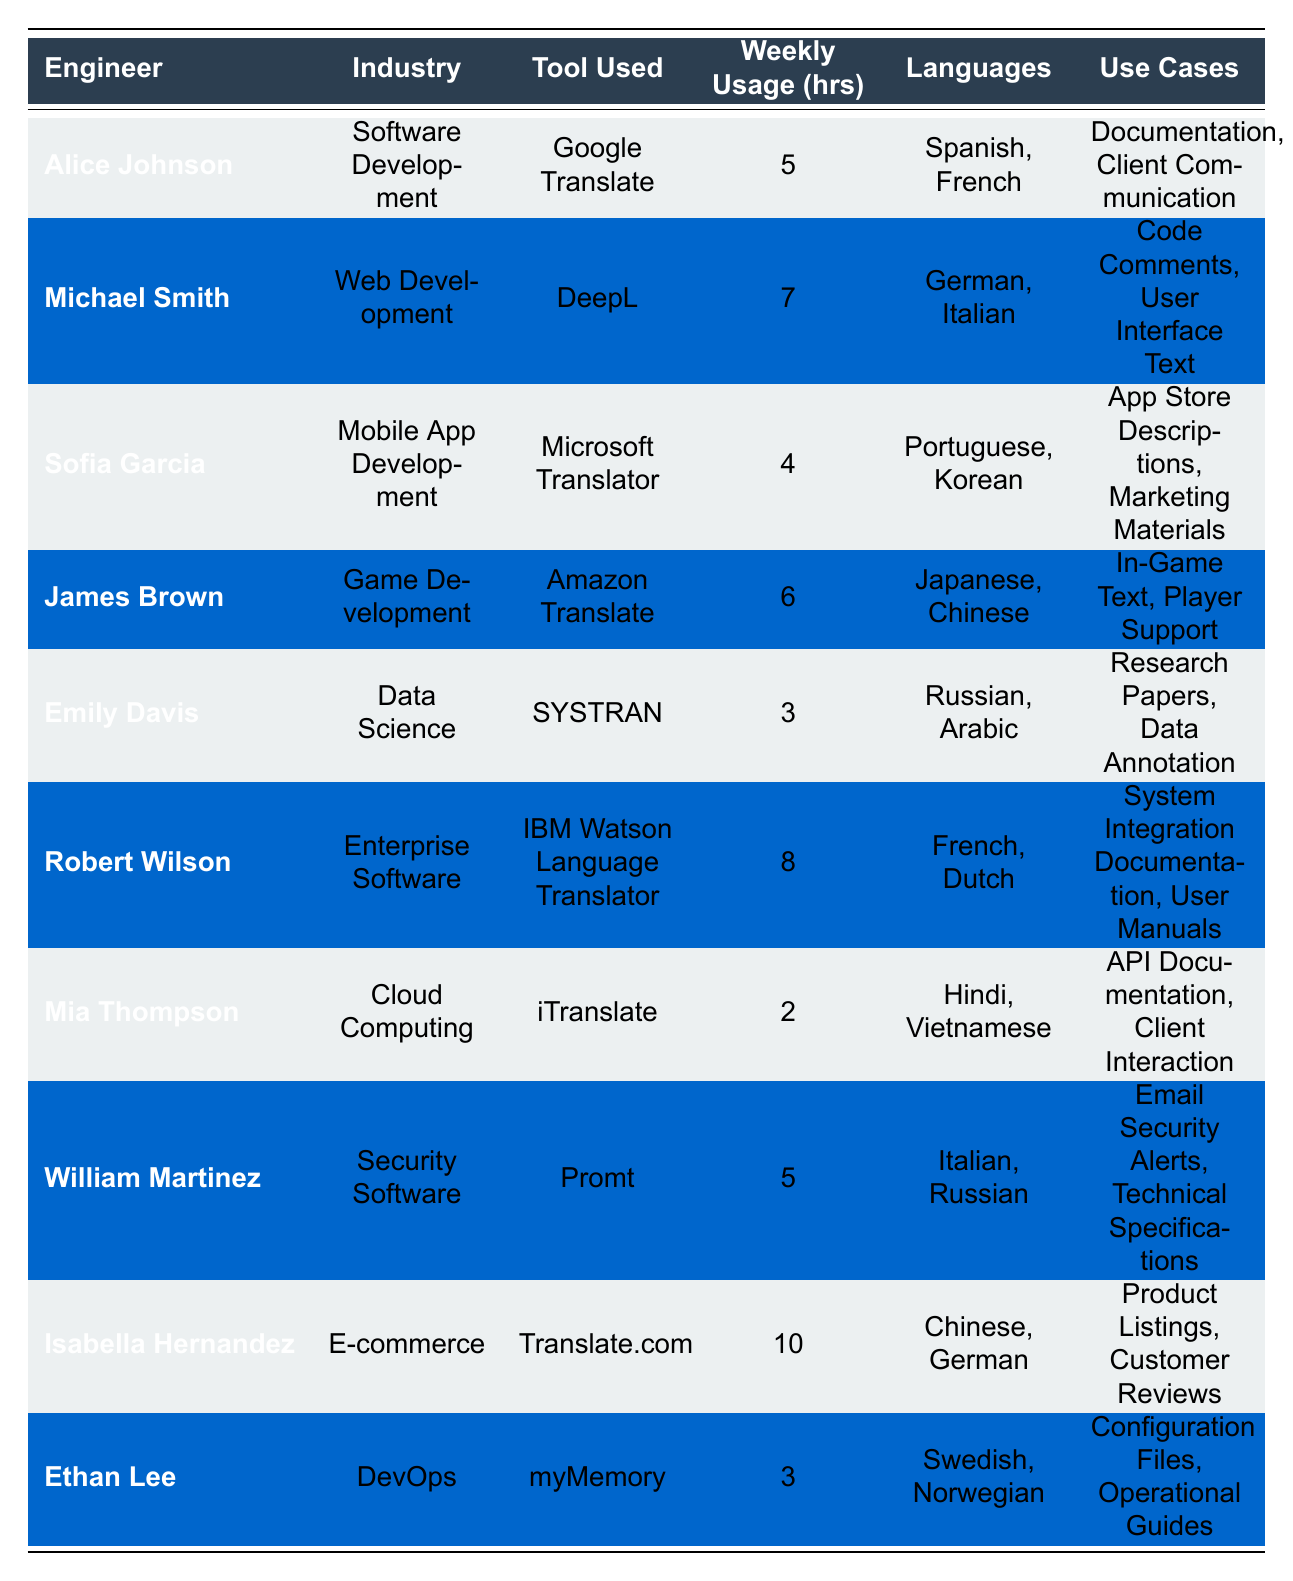What is the weekly usage of machine translation tools for Robert Wilson? According to the table, Robert Wilson uses a machine translation tool for 8 hours a week.
Answer: 8 hours How many languages does William Martinez translate? The table lists two languages for William Martinez: Italian and Russian, which means he translates a total of 2 languages.
Answer: 2 languages Which tool is used by the engineer in Mobile App Development? Sofia Garcia, who is in Mobile App Development, uses Microsoft Translator.
Answer: Microsoft Translator What is the average weekly usage of machine translation tools among the listed engineers? To calculate the average, sum the weekly usage hours (5 + 7 + 4 + 6 + 3 + 8 + 2 + 5 + 10 + 3 = 53) and divide by the number of engineers (10). The average is 53/10 = 5.3 hours.
Answer: 5.3 hours Is it true that all engineers use different translation tools? Observing the table, each engineer is associated with a unique tool without any duplications, confirming the statement is true.
Answer: Yes Which engineer uses the tool that has the highest weekly usage hours? Isabella Hernandez has the highest usage hours, utilizing Translate.com for 10 hours.
Answer: Isabella Hernandez What industries use more than 5 hours of machine translation weekly? Three engineers exceed 5 hours: Michael Smith (7), James Brown (6), and Robert Wilson (8), thus industries include Web Development, Game Development, and Enterprise Software.
Answer: Web Development, Game Development, Enterprise Software In terms of use cases, what common areas are targeted by machine translation according to the table? The table lists multiple use cases such as documentation, user interface text, app store descriptions, marketing materials, and more, indicating common areas like client communication and technical documentation.
Answer: Documentation and client communication 